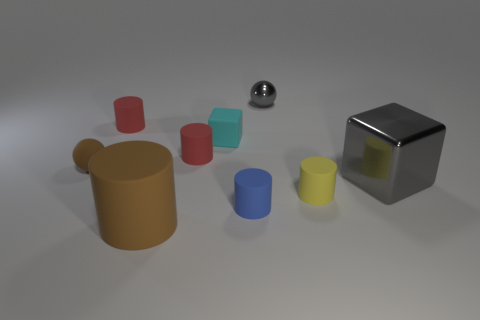The sphere that is to the left of the red cylinder on the left side of the large cylinder is made of what material?
Your answer should be compact. Rubber. There is a sphere that is right of the small matte cube; what is its size?
Provide a short and direct response. Small. How many brown objects are either balls or small blocks?
Your answer should be compact. 1. What is the material of the cyan thing that is the same shape as the big gray thing?
Your answer should be very brief. Rubber. Are there the same number of matte things on the right side of the big brown thing and metal cylinders?
Give a very brief answer. No. What is the size of the matte cylinder that is both in front of the matte ball and on the left side of the tiny cyan rubber thing?
Your response must be concise. Large. Is there anything else that has the same color as the rubber block?
Your answer should be very brief. No. How big is the metallic thing in front of the brown thing behind the tiny yellow thing?
Ensure brevity in your answer.  Large. What color is the thing that is behind the cyan matte block and right of the tiny cyan matte thing?
Ensure brevity in your answer.  Gray. How many other objects are the same size as the matte ball?
Your response must be concise. 6. 